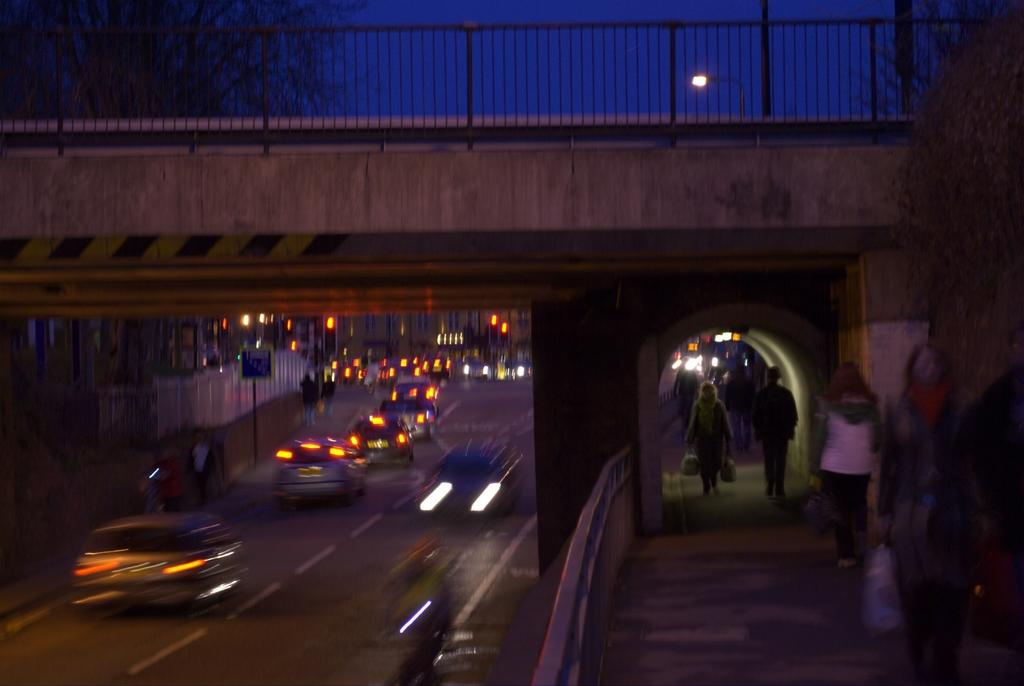What are the people in the image doing? The people in the image are standing on the footpath. What can be seen on the road in the image? There are cars parked on the road. What structure is visible at the top of the image? There is a bridge visible at the top of the image. What type of blade is being used by the friend in the image? There is no friend or blade present in the image. 